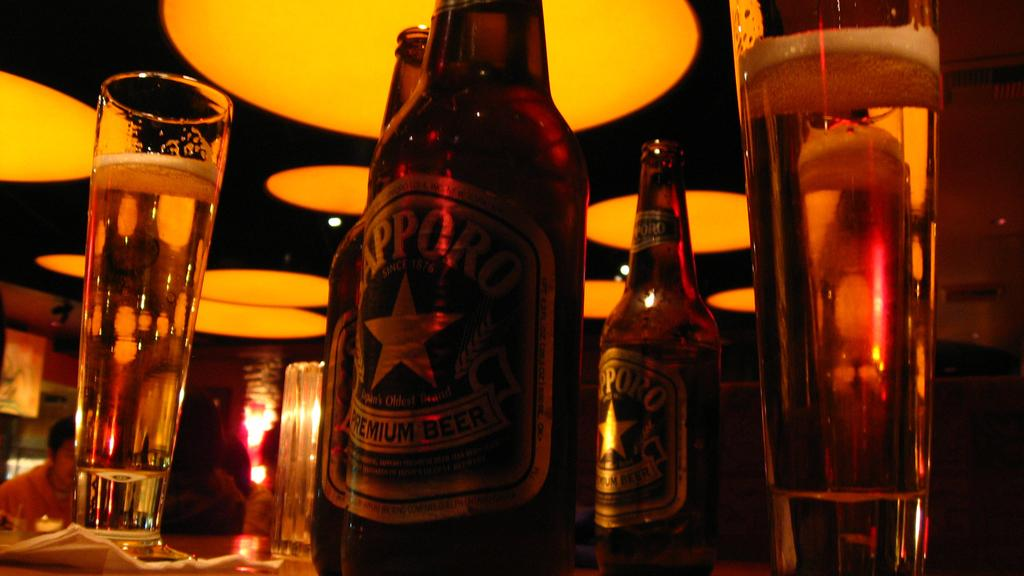What type of location is depicted in the image? The image is of the inside of a location. What can be seen in the foreground of the image? There is a glass of drink and bottles placed on the top of a table in the foreground of the image. What is visible in the background of the image? There are lights and a group of persons in the background of the image. Where is the pail located in the image? There is no pail present in the image. What type of sink is visible in the background of the image? There is no sink present in the image. 